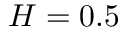<formula> <loc_0><loc_0><loc_500><loc_500>H = 0 . 5</formula> 